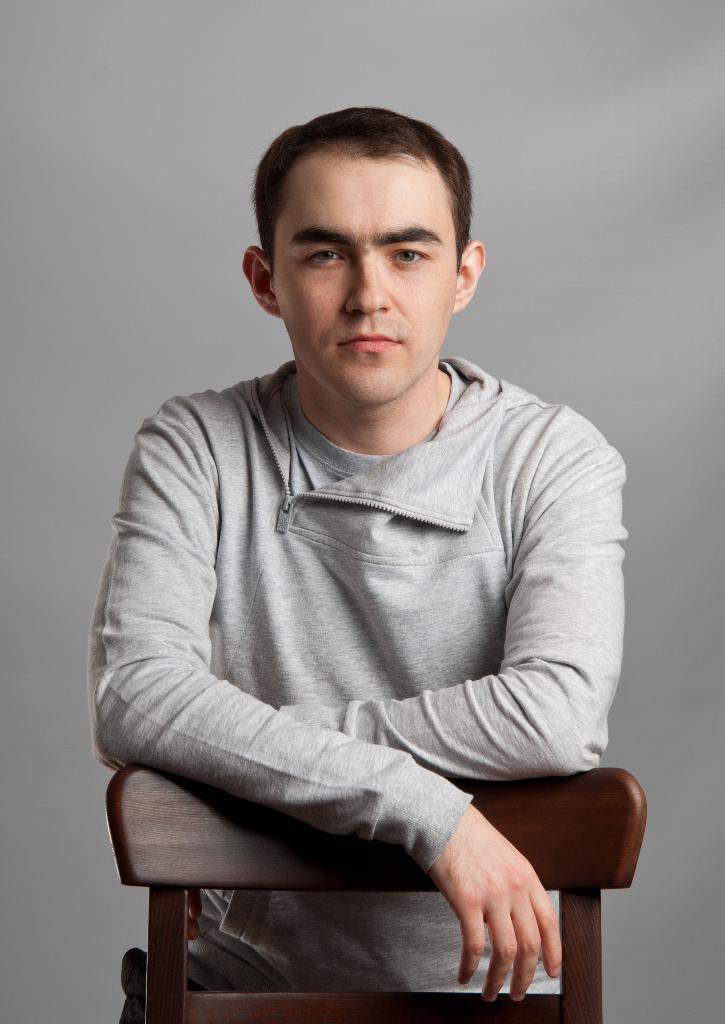Can you describe this image briefly? In this picture I can see a man and a chair and I can see a plain background. 